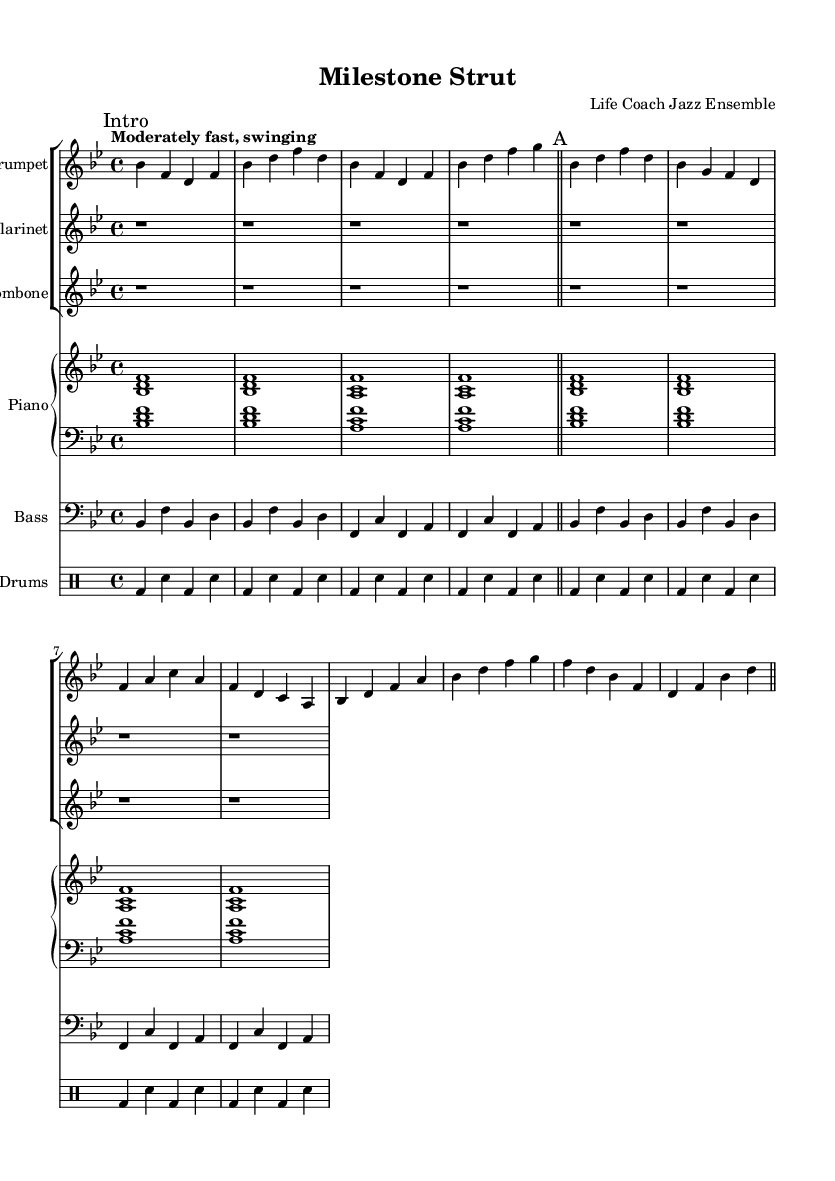What is the key signature of this music? The key signature is B flat major, which has two flats: B flat and E flat. This can be identified at the beginning of the staff.
Answer: B flat major What is the time signature of this piece? The time signature shown in the sheet music is 4/4, indicated by the two numbers at the beginning. The top number (4) shows that there are four beats per measure, and the bottom number (4) indicates that the quarter note gets one beat.
Answer: 4/4 What is the tempo marking of the music? The tempo marking indicates "Moderately fast, swinging," which gives performers an idea of the speed and style of the piece. The tempo notation is typically located at the beginning of the music, below the title.
Answer: Moderately fast, swinging How many measures are present in section A? Section A consists of four measures, as indicated by the repeating structure and the measure bars in the sheet music. Each section is delineated clearly by bar lines.
Answer: Four measures What instruments are included in this ensemble? The ensemble includes trumpet, clarinet, trombone, piano, bass, and drums. This can be determined by looking at the staff instrumentation labeled at the start of each staff group.
Answer: Trumpet, clarinet, trombone, piano, bass, drums Which musical style does this piece represent? This piece represents New Orleans-style jazz, a genre known for its lively rhythms and improvisational elements. The presence of instruments typical in jazz and the overall swing feel support this categorization.
Answer: New Orleans-style jazz 